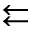Convert formula to latex. <formula><loc_0><loc_0><loc_500><loc_500>\left l e f t a r r o w s</formula> 